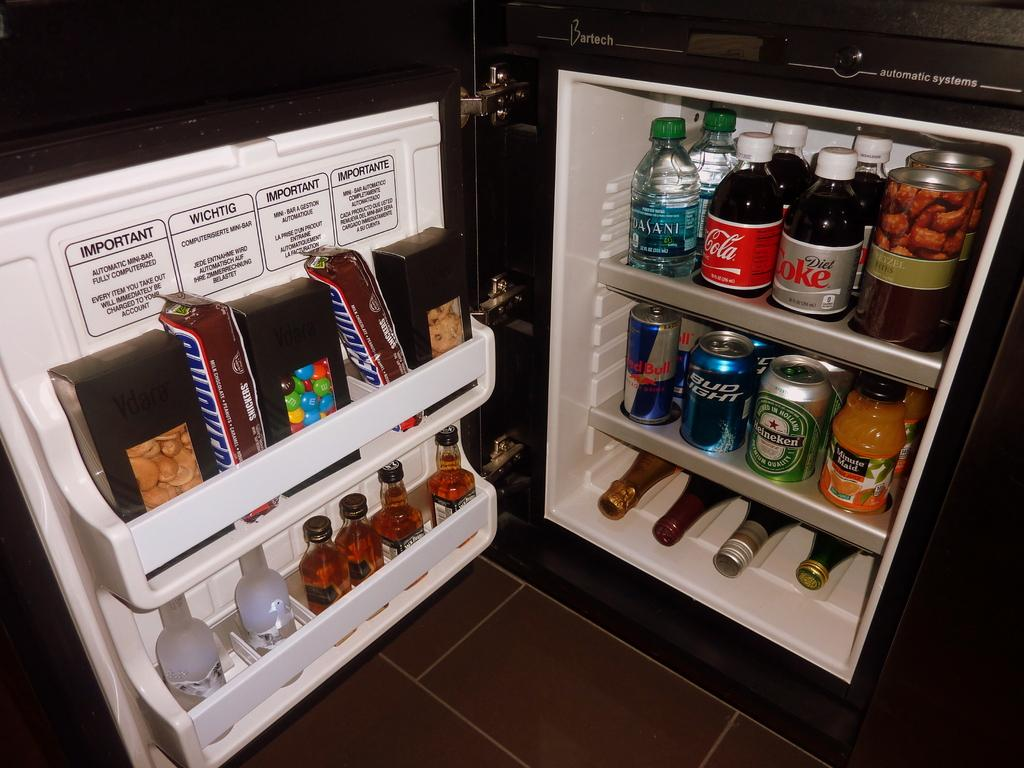<image>
Describe the image concisely. mini fridge full of water, coke, bud light, snickers and other goodies 